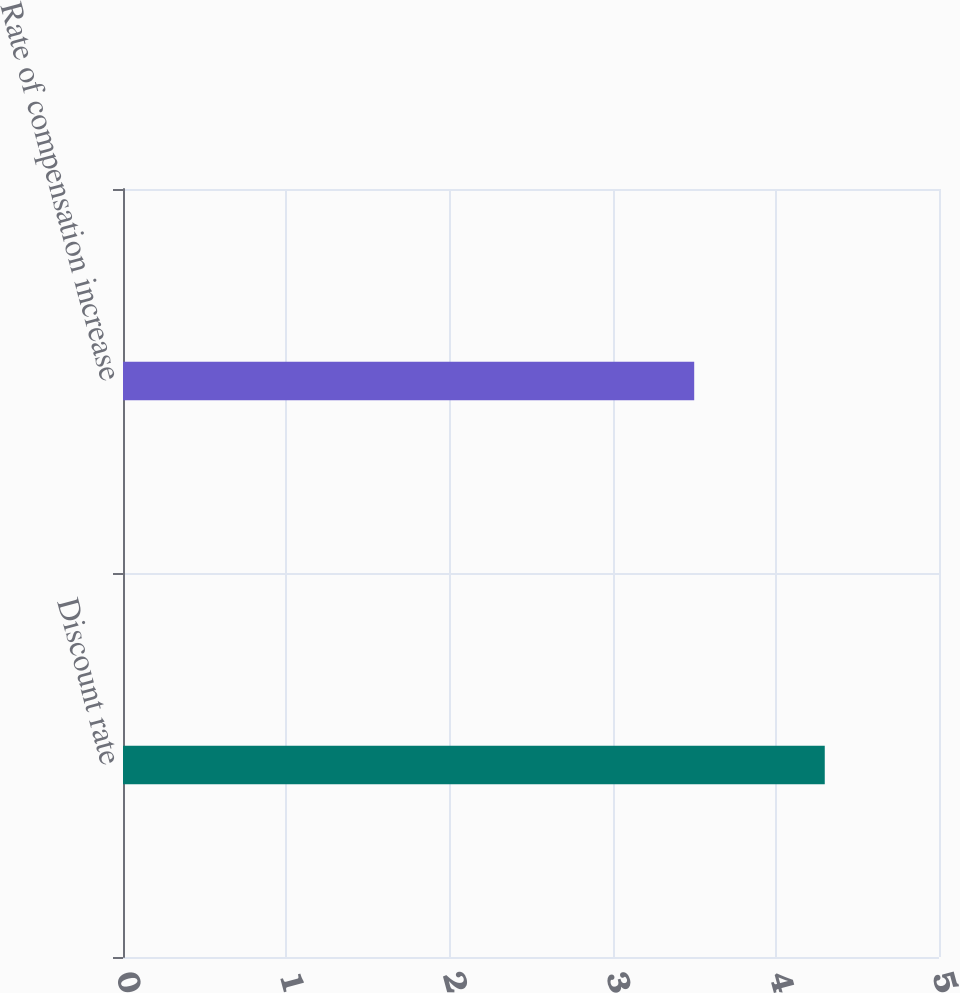Convert chart. <chart><loc_0><loc_0><loc_500><loc_500><bar_chart><fcel>Discount rate<fcel>Rate of compensation increase<nl><fcel>4.3<fcel>3.5<nl></chart> 